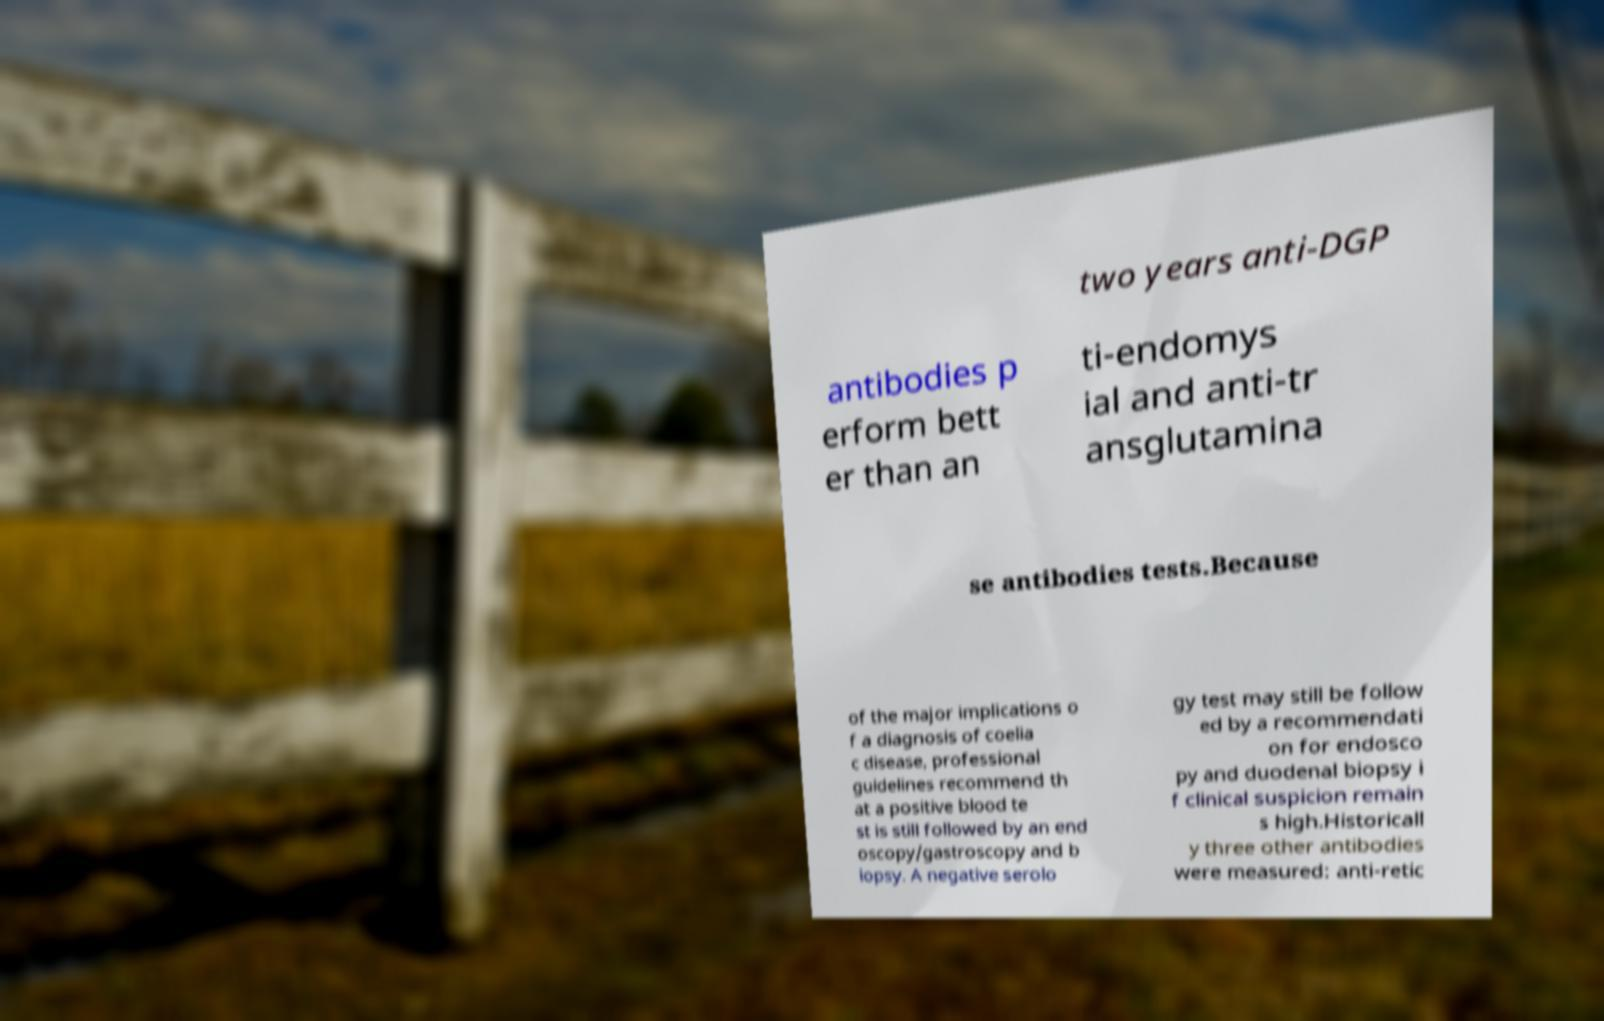What messages or text are displayed in this image? I need them in a readable, typed format. two years anti-DGP antibodies p erform bett er than an ti-endomys ial and anti-tr ansglutamina se antibodies tests.Because of the major implications o f a diagnosis of coelia c disease, professional guidelines recommend th at a positive blood te st is still followed by an end oscopy/gastroscopy and b iopsy. A negative serolo gy test may still be follow ed by a recommendati on for endosco py and duodenal biopsy i f clinical suspicion remain s high.Historicall y three other antibodies were measured: anti-retic 